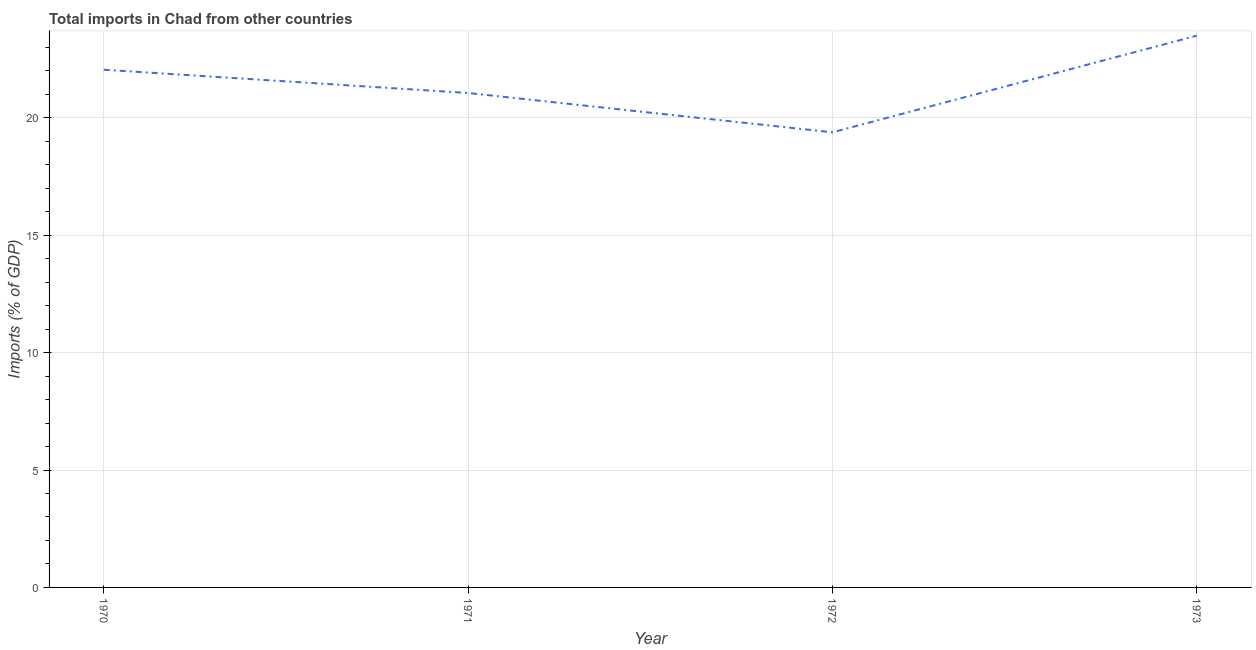What is the total imports in 1970?
Your answer should be very brief. 22.05. Across all years, what is the maximum total imports?
Make the answer very short. 23.5. Across all years, what is the minimum total imports?
Offer a terse response. 19.38. In which year was the total imports maximum?
Provide a short and direct response. 1973. In which year was the total imports minimum?
Your response must be concise. 1972. What is the sum of the total imports?
Your answer should be compact. 85.99. What is the difference between the total imports in 1970 and 1972?
Provide a succinct answer. 2.67. What is the average total imports per year?
Your answer should be compact. 21.5. What is the median total imports?
Your response must be concise. 21.55. What is the ratio of the total imports in 1970 to that in 1973?
Your answer should be compact. 0.94. What is the difference between the highest and the second highest total imports?
Offer a terse response. 1.45. Is the sum of the total imports in 1970 and 1972 greater than the maximum total imports across all years?
Your answer should be compact. Yes. What is the difference between the highest and the lowest total imports?
Keep it short and to the point. 4.12. In how many years, is the total imports greater than the average total imports taken over all years?
Offer a terse response. 2. How many lines are there?
Your answer should be compact. 1. What is the difference between two consecutive major ticks on the Y-axis?
Offer a very short reply. 5. Does the graph contain any zero values?
Provide a short and direct response. No. What is the title of the graph?
Provide a short and direct response. Total imports in Chad from other countries. What is the label or title of the X-axis?
Provide a short and direct response. Year. What is the label or title of the Y-axis?
Provide a short and direct response. Imports (% of GDP). What is the Imports (% of GDP) of 1970?
Keep it short and to the point. 22.05. What is the Imports (% of GDP) of 1971?
Give a very brief answer. 21.06. What is the Imports (% of GDP) in 1972?
Provide a succinct answer. 19.38. What is the Imports (% of GDP) of 1973?
Offer a very short reply. 23.5. What is the difference between the Imports (% of GDP) in 1970 and 1971?
Ensure brevity in your answer.  0.99. What is the difference between the Imports (% of GDP) in 1970 and 1972?
Ensure brevity in your answer.  2.67. What is the difference between the Imports (% of GDP) in 1970 and 1973?
Make the answer very short. -1.45. What is the difference between the Imports (% of GDP) in 1971 and 1972?
Keep it short and to the point. 1.67. What is the difference between the Imports (% of GDP) in 1971 and 1973?
Your answer should be very brief. -2.44. What is the difference between the Imports (% of GDP) in 1972 and 1973?
Provide a short and direct response. -4.12. What is the ratio of the Imports (% of GDP) in 1970 to that in 1971?
Make the answer very short. 1.05. What is the ratio of the Imports (% of GDP) in 1970 to that in 1972?
Provide a short and direct response. 1.14. What is the ratio of the Imports (% of GDP) in 1970 to that in 1973?
Provide a succinct answer. 0.94. What is the ratio of the Imports (% of GDP) in 1971 to that in 1972?
Your response must be concise. 1.09. What is the ratio of the Imports (% of GDP) in 1971 to that in 1973?
Make the answer very short. 0.9. What is the ratio of the Imports (% of GDP) in 1972 to that in 1973?
Offer a very short reply. 0.82. 